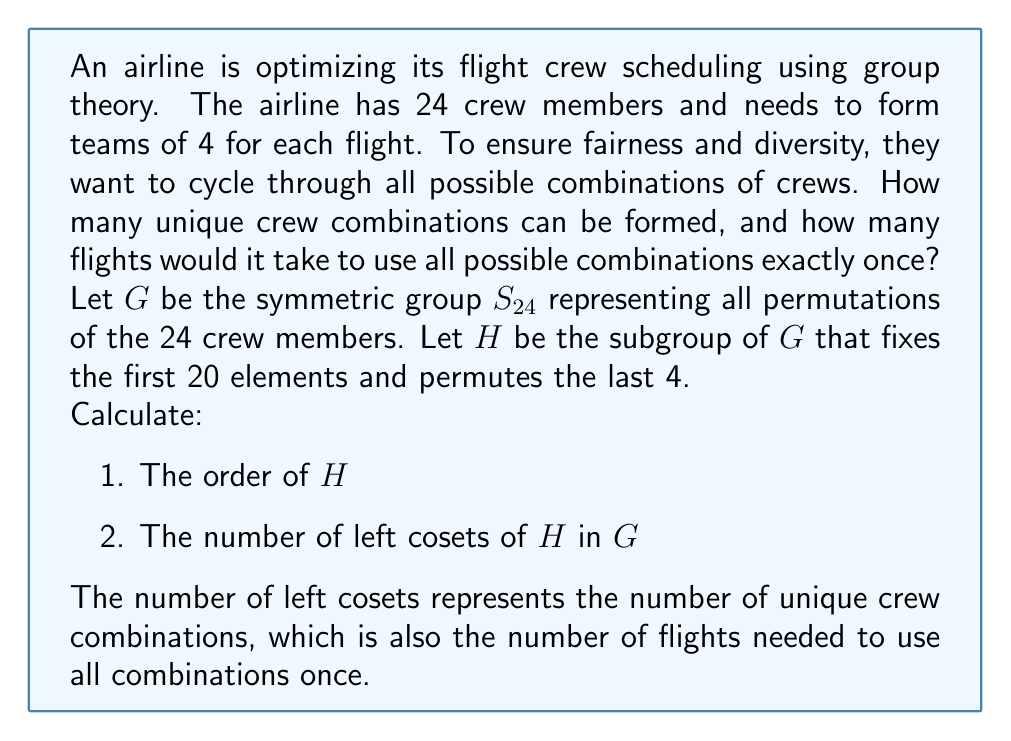Solve this math problem. Let's approach this step-by-step:

1) First, let's calculate the order of $H$:
   - $H$ is effectively the symmetric group on 4 elements, $S_4$, as it only permutes the last 4 elements.
   - The order of $S_4$ is 4! = 24
   - Therefore, $|H| = 24$

2) Now, let's calculate the number of left cosets of $H$ in $G$:
   - We can use the Lagrange's theorem, which states that for a subgroup $H$ of a finite group $G$:
     $$[G:H] = \frac{|G|}{|H|}$$
   where $[G:H]$ is the number of left cosets of $H$ in $G$.

   - We know that $|G| = |S_{24}| = 24! = 620,448,401,733,239,439,360,000$
   - We calculated earlier that $|H| = 24$

   - Therefore:
     $$[G:H] = \frac{|G|}{|H|} = \frac{24!}{24} = 23! = 25,852,016,738,884,976,640,000$$

This number represents both the number of unique crew combinations and the number of flights needed to use all combinations exactly once.
Answer: 25,852,016,738,884,976,640,000 unique combinations and flights 